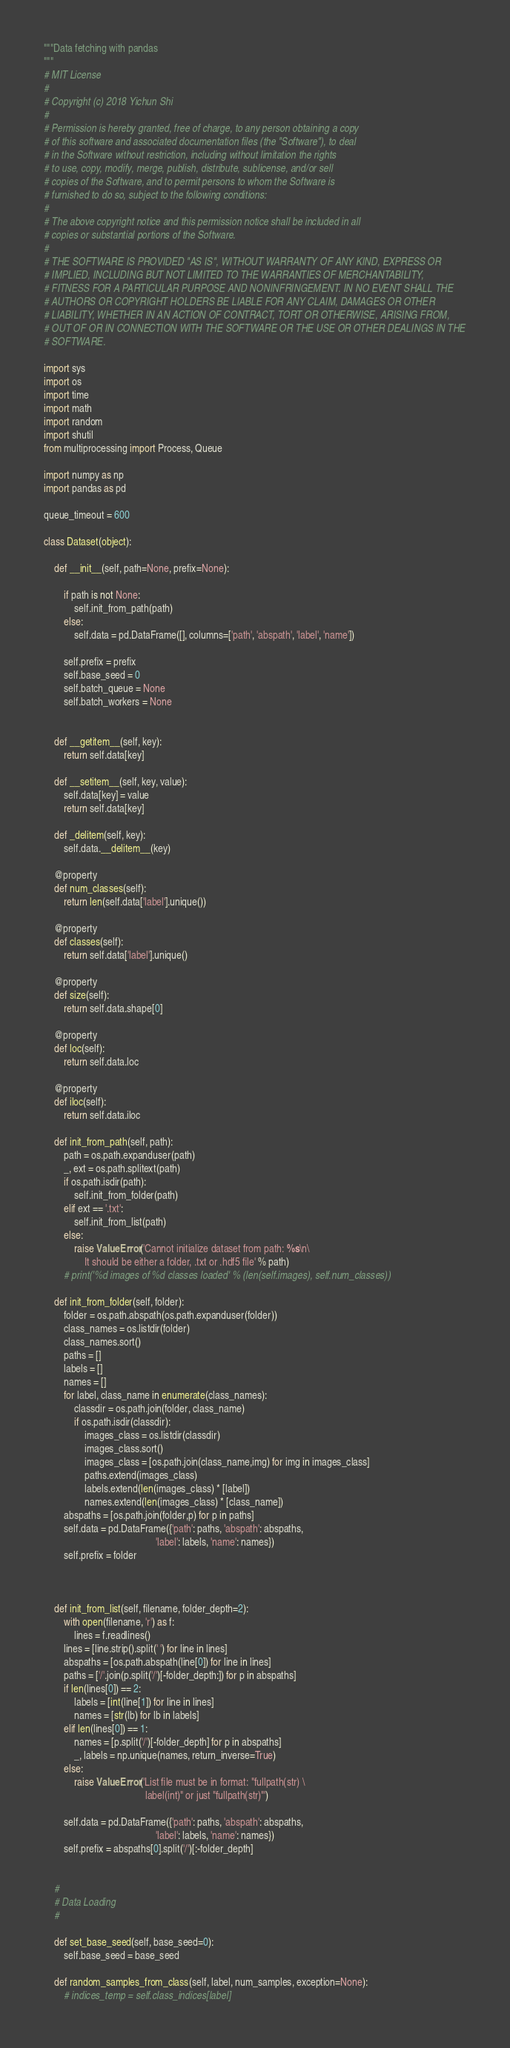Convert code to text. <code><loc_0><loc_0><loc_500><loc_500><_Python_>"""Data fetching with pandas
"""
# MIT License
# 
# Copyright (c) 2018 Yichun Shi
# 
# Permission is hereby granted, free of charge, to any person obtaining a copy
# of this software and associated documentation files (the "Software"), to deal
# in the Software without restriction, including without limitation the rights
# to use, copy, modify, merge, publish, distribute, sublicense, and/or sell
# copies of the Software, and to permit persons to whom the Software is
# furnished to do so, subject to the following conditions:
# 
# The above copyright notice and this permission notice shall be included in all
# copies or substantial portions of the Software.
# 
# THE SOFTWARE IS PROVIDED "AS IS", WITHOUT WARRANTY OF ANY KIND, EXPRESS OR
# IMPLIED, INCLUDING BUT NOT LIMITED TO THE WARRANTIES OF MERCHANTABILITY,
# FITNESS FOR A PARTICULAR PURPOSE AND NONINFRINGEMENT. IN NO EVENT SHALL THE
# AUTHORS OR COPYRIGHT HOLDERS BE LIABLE FOR ANY CLAIM, DAMAGES OR OTHER
# LIABILITY, WHETHER IN AN ACTION OF CONTRACT, TORT OR OTHERWISE, ARISING FROM,
# OUT OF OR IN CONNECTION WITH THE SOFTWARE OR THE USE OR OTHER DEALINGS IN THE
# SOFTWARE.

import sys
import os
import time
import math
import random
import shutil
from multiprocessing import Process, Queue

import numpy as np
import pandas as pd

queue_timeout = 600

class Dataset(object):

    def __init__(self, path=None, prefix=None):

        if path is not None:
            self.init_from_path(path)
        else:
            self.data = pd.DataFrame([], columns=['path', 'abspath', 'label', 'name'])

        self.prefix = prefix
        self.base_seed = 0
        self.batch_queue = None
        self.batch_workers = None
       

    def __getitem__(self, key):
        return self.data[key]

    def __setitem__(self, key, value):
        self.data[key] = value
        return self.data[key]

    def _delitem(self, key):
        self.data.__delitem__(key)

    @property
    def num_classes(self):
        return len(self.data['label'].unique())

    @property
    def classes(self):
        return self.data['label'].unique()

    @property
    def size(self):
        return self.data.shape[0]

    @property
    def loc(self):
        return self.data.loc       

    @property
    def iloc(self):
        return self.data.iloc

    def init_from_path(self, path):
        path = os.path.expanduser(path)
        _, ext = os.path.splitext(path)
        if os.path.isdir(path):
            self.init_from_folder(path)
        elif ext == '.txt':
            self.init_from_list(path)
        else:
            raise ValueError('Cannot initialize dataset from path: %s\n\
                It should be either a folder, .txt or .hdf5 file' % path)
        # print('%d images of %d classes loaded' % (len(self.images), self.num_classes))

    def init_from_folder(self, folder):
        folder = os.path.abspath(os.path.expanduser(folder))
        class_names = os.listdir(folder)
        class_names.sort()
        paths = []
        labels = []
        names = []
        for label, class_name in enumerate(class_names):
            classdir = os.path.join(folder, class_name)
            if os.path.isdir(classdir):
                images_class = os.listdir(classdir)
                images_class.sort()
                images_class = [os.path.join(class_name,img) for img in images_class]
                paths.extend(images_class)
                labels.extend(len(images_class) * [label])
                names.extend(len(images_class) * [class_name])
        abspaths = [os.path.join(folder,p) for p in paths]
        self.data = pd.DataFrame({'path': paths, 'abspath': abspaths, 
                                            'label': labels, 'name': names})
        self.prefix = folder

    

    def init_from_list(self, filename, folder_depth=2):
        with open(filename, 'r') as f:
            lines = f.readlines()
        lines = [line.strip().split(' ') for line in lines]
        abspaths = [os.path.abspath(line[0]) for line in lines]
        paths = ['/'.join(p.split('/')[-folder_depth:]) for p in abspaths]
        if len(lines[0]) == 2:
            labels = [int(line[1]) for line in lines]
            names = [str(lb) for lb in labels]
        elif len(lines[0]) == 1:
            names = [p.split('/')[-folder_depth] for p in abspaths]
            _, labels = np.unique(names, return_inverse=True)
        else:
            raise ValueError('List file must be in format: "fullpath(str) \
                                        label(int)" or just "fullpath(str)"')

        self.data = pd.DataFrame({'path': paths, 'abspath': abspaths, 
                                            'label': labels, 'name': names})
        self.prefix = abspaths[0].split('/')[:-folder_depth]


    #
    # Data Loading
    #

    def set_base_seed(self, base_seed=0):
        self.base_seed = base_seed

    def random_samples_from_class(self, label, num_samples, exception=None):
        # indices_temp = self.class_indices[label]</code> 